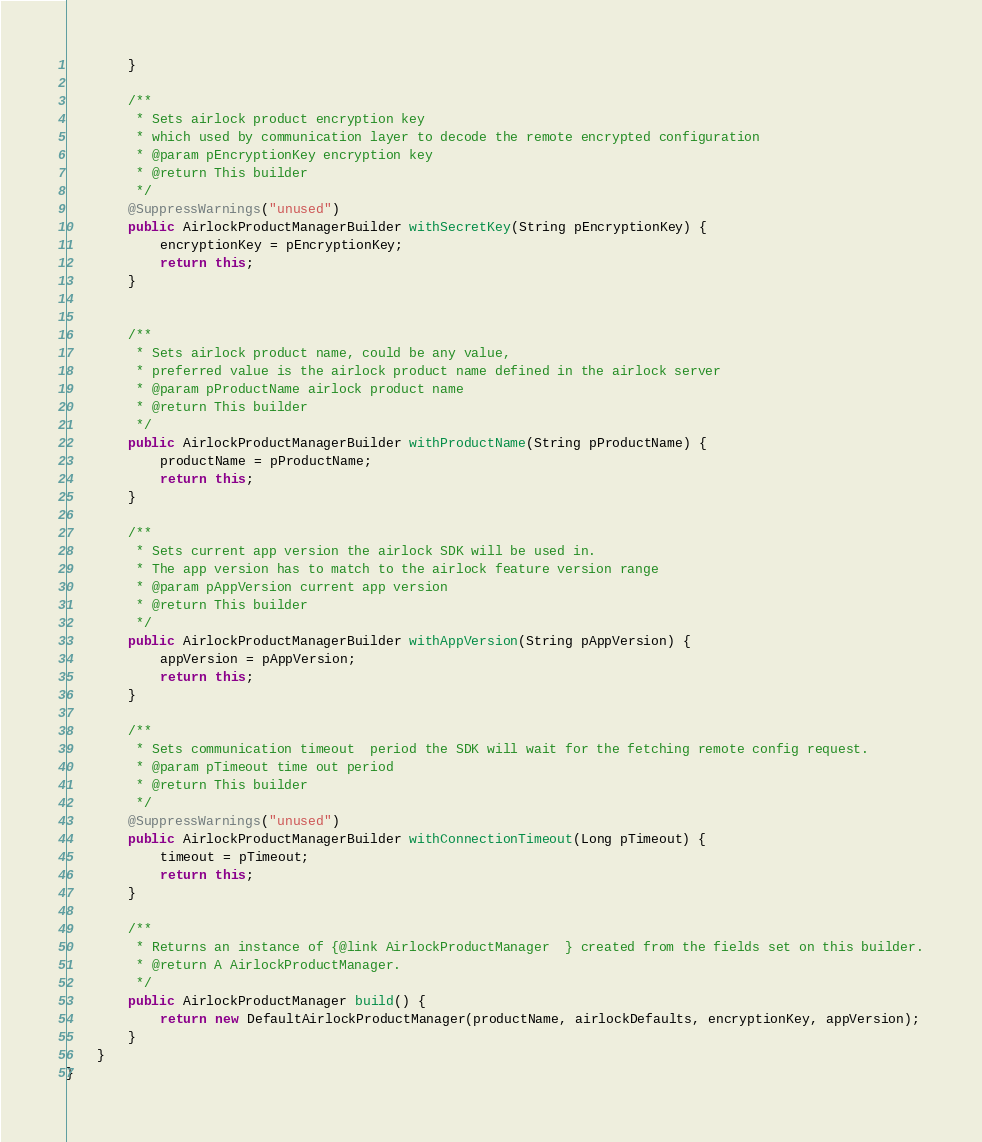Convert code to text. <code><loc_0><loc_0><loc_500><loc_500><_Java_>        }

        /**
         * Sets airlock product encryption key
         * which used by communication layer to decode the remote encrypted configuration
         * @param pEncryptionKey encryption key
         * @return This builder
         */
        @SuppressWarnings("unused")
        public AirlockProductManagerBuilder withSecretKey(String pEncryptionKey) {
            encryptionKey = pEncryptionKey;
            return this;
        }


        /**
         * Sets airlock product name, could be any value,
         * preferred value is the airlock product name defined in the airlock server
         * @param pProductName airlock product name
         * @return This builder
         */
        public AirlockProductManagerBuilder withProductName(String pProductName) {
            productName = pProductName;
            return this;
        }

        /**
         * Sets current app version the airlock SDK will be used in.
         * The app version has to match to the airlock feature version range
         * @param pAppVersion current app version
         * @return This builder
         */
        public AirlockProductManagerBuilder withAppVersion(String pAppVersion) {
            appVersion = pAppVersion;
            return this;
        }

        /**
         * Sets communication timeout  period the SDK will wait for the fetching remote config request.
         * @param pTimeout time out period
         * @return This builder
         */
        @SuppressWarnings("unused")
        public AirlockProductManagerBuilder withConnectionTimeout(Long pTimeout) {
            timeout = pTimeout;
            return this;
        }

        /**
         * Returns an instance of {@link AirlockProductManager  } created from the fields set on this builder.
         * @return A AirlockProductManager.
         */
        public AirlockProductManager build() {
            return new DefaultAirlockProductManager(productName, airlockDefaults, encryptionKey, appVersion);
        }
    }
}
</code> 